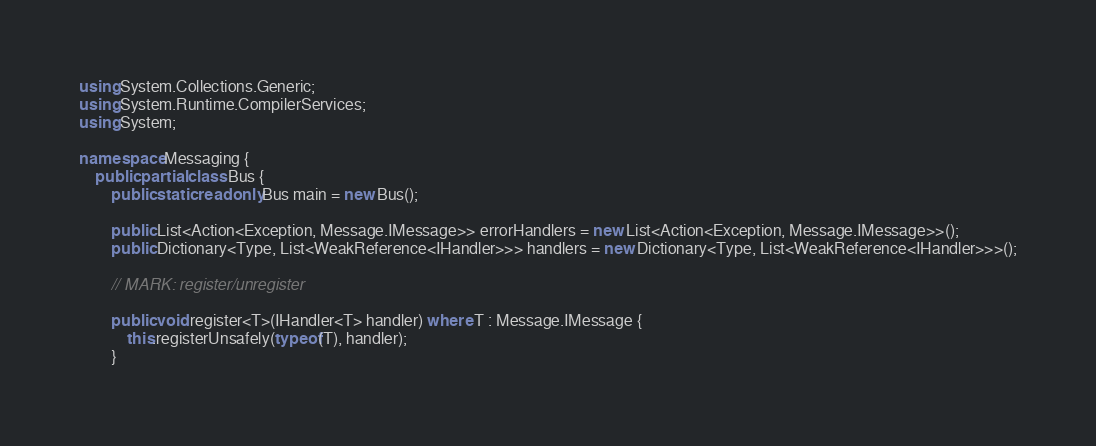Convert code to text. <code><loc_0><loc_0><loc_500><loc_500><_C#_>using System.Collections.Generic;
using System.Runtime.CompilerServices;
using System;

namespace Messaging {
	public partial class Bus {
		public static readonly Bus main = new Bus();

		public List<Action<Exception, Message.IMessage>> errorHandlers = new List<Action<Exception, Message.IMessage>>();
		public Dictionary<Type, List<WeakReference<IHandler>>> handlers = new Dictionary<Type, List<WeakReference<IHandler>>>();

		// MARK: register/unregister

		public void register<T>(IHandler<T> handler) where T : Message.IMessage {
			this.registerUnsafely(typeof(T), handler);
		}
</code> 